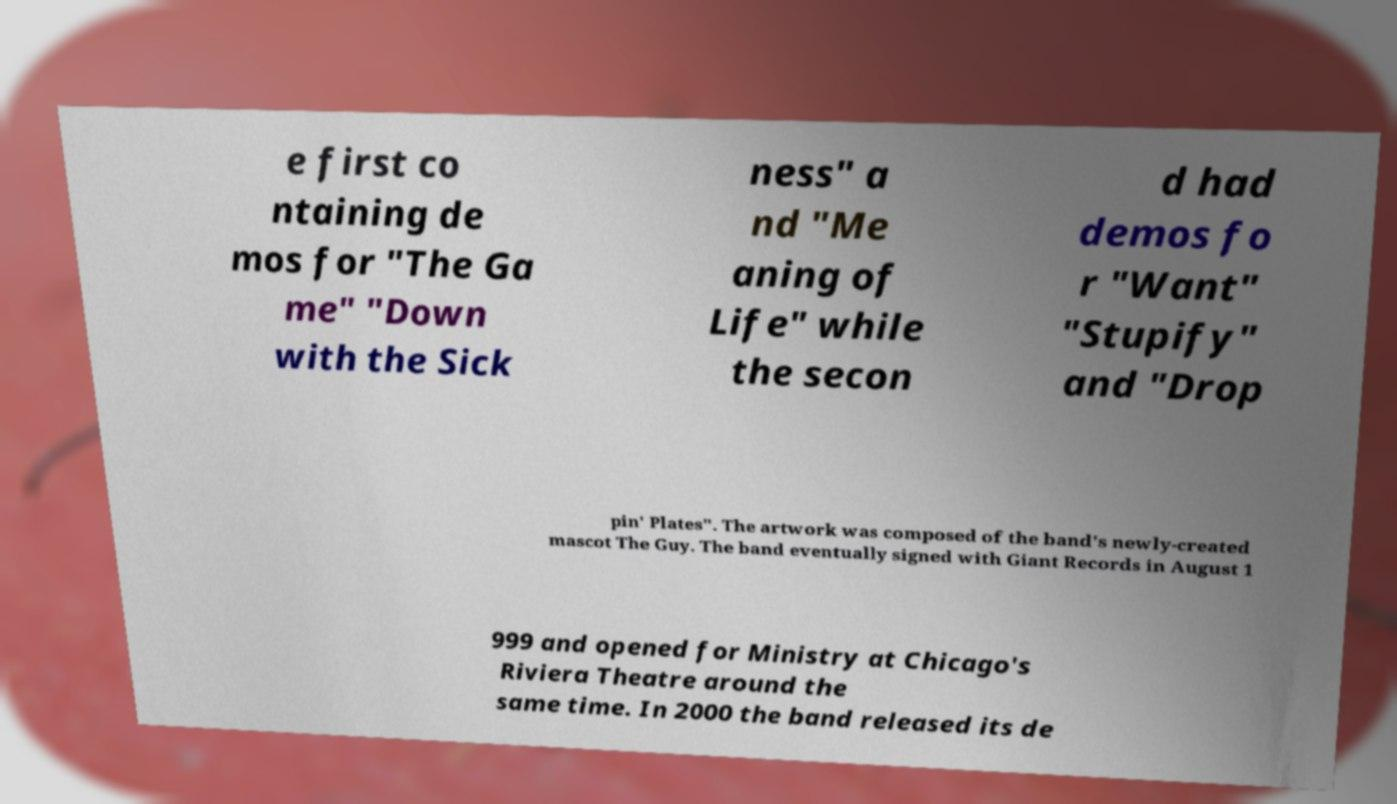Can you read and provide the text displayed in the image?This photo seems to have some interesting text. Can you extract and type it out for me? e first co ntaining de mos for "The Ga me" "Down with the Sick ness" a nd "Me aning of Life" while the secon d had demos fo r "Want" "Stupify" and "Drop pin' Plates". The artwork was composed of the band's newly-created mascot The Guy. The band eventually signed with Giant Records in August 1 999 and opened for Ministry at Chicago's Riviera Theatre around the same time. In 2000 the band released its de 